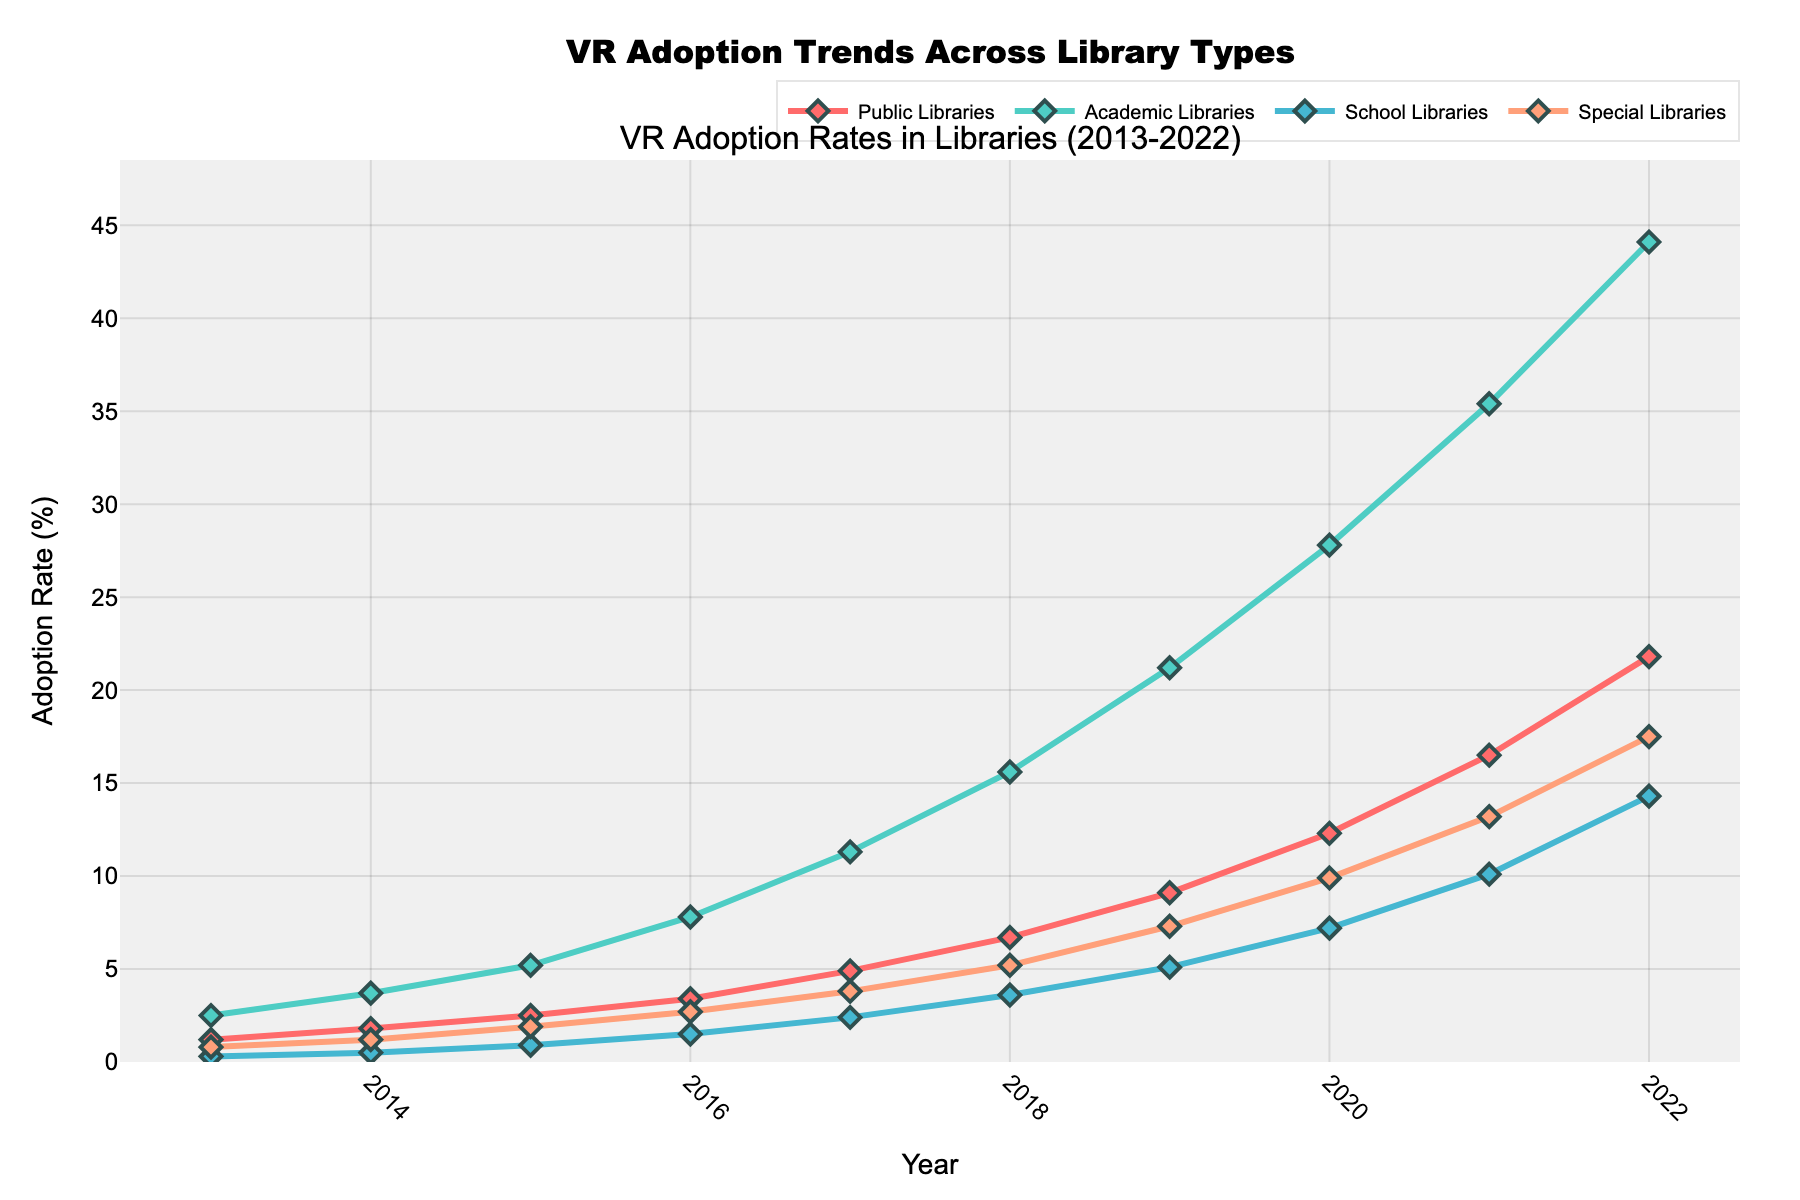What is the adoption rate of VR technologies in Public Libraries in 2015? Locate the data point for Public Libraries in 2015 on the line chart. The adoption rate is 2.5%
Answer: 2.5% Which library type had the highest adoption rate of VR technologies in 2018? Compare the adoption rates of all library types in 2018 from the figure. Academic Libraries had the highest adoption rate at 15.6%
Answer: Academic Libraries By how much did the adoption rate of VR technologies in School Libraries increase from 2013 to 2022? Subtract the adoption rate of School Libraries in 2013 from that in 2022 (14.3 - 0.3 = 14)
Answer: 14% Which library type showed the fastest growth in VR adoption rates between 2013 and 2022? Observe the slopes of each line representing different library types. Academic Libraries showed the fastest growth, going from 2.5% in 2013 to 44.1% in 2022
Answer: Academic Libraries Between 2016 and 2019, which library type experienced the largest increase in VR adoption rate? Calculate the difference in adoption rates between 2016 and 2019 for each library type: Public Libraries (9.1 - 3.4 = 5.7), Academic Libraries (21.2 - 7.8 = 13.4), School Libraries (5.1 - 1.5 = 3.6), Special Libraries (7.3 - 2.7 = 4.6). Academic Libraries experienced the largest increase
Answer: Academic Libraries In what year did Special Libraries first surpass a 10% adoption rate? Identify when the line representing Special Libraries crosses the 10% threshold. It happened in 2021
Answer: 2021 Compare the VR adoption rates of Public Libraries and School Libraries in 2020. Which one had a higher adoption rate? Refer to the figure for the adoption rates in 2020: Public Libraries (12.3%) and School Libraries (7.2%). Public Libraries had a higher adoption rate
Answer: Public Libraries How does the VR adoption trend in Public Libraries compare to that of Special Libraries from 2017 to 2020? Examine the respective lines for Public and Special Libraries from 2017 to 2020. Both show increasing trends, but Public Libraries had a steeper increase (4.9% to 12.3%) compared to Special Libraries (3.8% to 9.9%)
Answer: Public Libraries had a steeper increase What is the total adoption rate of VR technologies across all library types in 2018? Sum the adoption rates of all library types in 2018: 6.7 (Public) + 15.6 (Academic) + 3.6 (School) + 5.2 (Special) = 31.1
Answer: 31.1% 